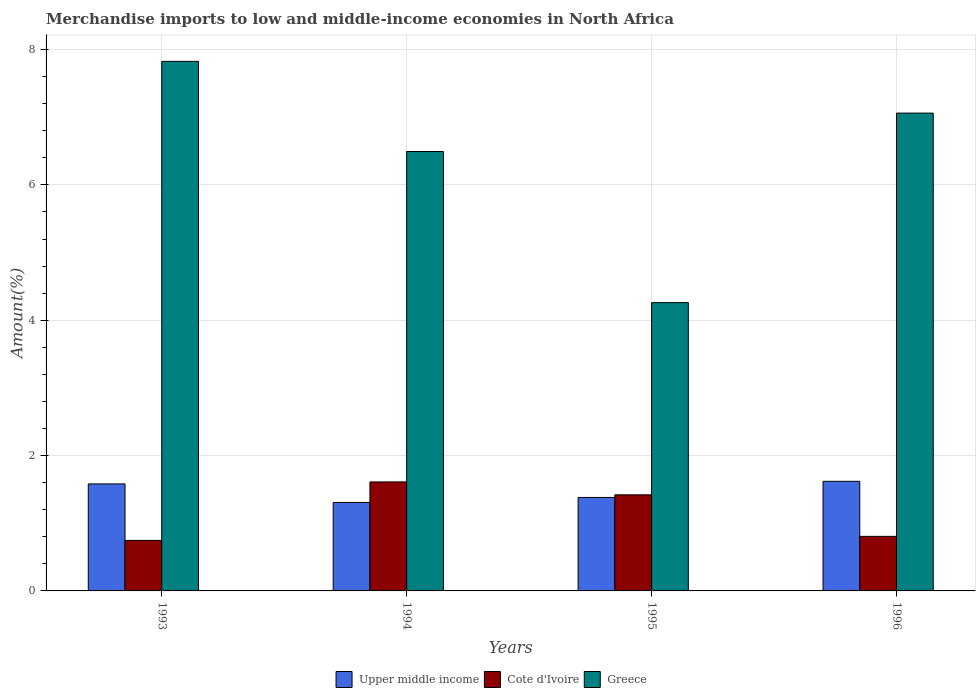How many groups of bars are there?
Your answer should be compact. 4. How many bars are there on the 1st tick from the left?
Offer a terse response. 3. What is the label of the 4th group of bars from the left?
Keep it short and to the point. 1996. What is the percentage of amount earned from merchandise imports in Greece in 1995?
Keep it short and to the point. 4.26. Across all years, what is the maximum percentage of amount earned from merchandise imports in Upper middle income?
Keep it short and to the point. 1.62. Across all years, what is the minimum percentage of amount earned from merchandise imports in Upper middle income?
Offer a terse response. 1.31. What is the total percentage of amount earned from merchandise imports in Upper middle income in the graph?
Keep it short and to the point. 5.89. What is the difference between the percentage of amount earned from merchandise imports in Upper middle income in 1994 and that in 1995?
Provide a short and direct response. -0.07. What is the difference between the percentage of amount earned from merchandise imports in Greece in 1993 and the percentage of amount earned from merchandise imports in Upper middle income in 1995?
Make the answer very short. 6.44. What is the average percentage of amount earned from merchandise imports in Greece per year?
Your answer should be very brief. 6.41. In the year 1996, what is the difference between the percentage of amount earned from merchandise imports in Cote d'Ivoire and percentage of amount earned from merchandise imports in Upper middle income?
Give a very brief answer. -0.81. In how many years, is the percentage of amount earned from merchandise imports in Upper middle income greater than 5.6 %?
Ensure brevity in your answer.  0. What is the ratio of the percentage of amount earned from merchandise imports in Greece in 1993 to that in 1995?
Your answer should be very brief. 1.84. Is the difference between the percentage of amount earned from merchandise imports in Cote d'Ivoire in 1993 and 1994 greater than the difference between the percentage of amount earned from merchandise imports in Upper middle income in 1993 and 1994?
Ensure brevity in your answer.  No. What is the difference between the highest and the second highest percentage of amount earned from merchandise imports in Greece?
Keep it short and to the point. 0.76. What is the difference between the highest and the lowest percentage of amount earned from merchandise imports in Upper middle income?
Offer a terse response. 0.31. In how many years, is the percentage of amount earned from merchandise imports in Cote d'Ivoire greater than the average percentage of amount earned from merchandise imports in Cote d'Ivoire taken over all years?
Provide a succinct answer. 2. Is the sum of the percentage of amount earned from merchandise imports in Cote d'Ivoire in 1993 and 1996 greater than the maximum percentage of amount earned from merchandise imports in Greece across all years?
Your response must be concise. No. What does the 1st bar from the left in 1995 represents?
Offer a very short reply. Upper middle income. Are all the bars in the graph horizontal?
Ensure brevity in your answer.  No. What is the difference between two consecutive major ticks on the Y-axis?
Your answer should be very brief. 2. Does the graph contain any zero values?
Your answer should be very brief. No. How many legend labels are there?
Give a very brief answer. 3. What is the title of the graph?
Provide a short and direct response. Merchandise imports to low and middle-income economies in North Africa. Does "Niger" appear as one of the legend labels in the graph?
Give a very brief answer. No. What is the label or title of the Y-axis?
Your answer should be very brief. Amount(%). What is the Amount(%) of Upper middle income in 1993?
Your answer should be very brief. 1.58. What is the Amount(%) of Cote d'Ivoire in 1993?
Give a very brief answer. 0.75. What is the Amount(%) in Greece in 1993?
Make the answer very short. 7.83. What is the Amount(%) of Upper middle income in 1994?
Your answer should be very brief. 1.31. What is the Amount(%) in Cote d'Ivoire in 1994?
Offer a terse response. 1.61. What is the Amount(%) in Greece in 1994?
Provide a succinct answer. 6.49. What is the Amount(%) of Upper middle income in 1995?
Provide a succinct answer. 1.38. What is the Amount(%) in Cote d'Ivoire in 1995?
Your answer should be compact. 1.42. What is the Amount(%) of Greece in 1995?
Your response must be concise. 4.26. What is the Amount(%) in Upper middle income in 1996?
Keep it short and to the point. 1.62. What is the Amount(%) of Cote d'Ivoire in 1996?
Offer a very short reply. 0.81. What is the Amount(%) in Greece in 1996?
Your answer should be compact. 7.06. Across all years, what is the maximum Amount(%) of Upper middle income?
Your answer should be very brief. 1.62. Across all years, what is the maximum Amount(%) of Cote d'Ivoire?
Offer a terse response. 1.61. Across all years, what is the maximum Amount(%) in Greece?
Provide a succinct answer. 7.83. Across all years, what is the minimum Amount(%) of Upper middle income?
Your answer should be compact. 1.31. Across all years, what is the minimum Amount(%) in Cote d'Ivoire?
Give a very brief answer. 0.75. Across all years, what is the minimum Amount(%) in Greece?
Your response must be concise. 4.26. What is the total Amount(%) in Upper middle income in the graph?
Offer a very short reply. 5.89. What is the total Amount(%) in Cote d'Ivoire in the graph?
Keep it short and to the point. 4.58. What is the total Amount(%) of Greece in the graph?
Ensure brevity in your answer.  25.64. What is the difference between the Amount(%) in Upper middle income in 1993 and that in 1994?
Ensure brevity in your answer.  0.27. What is the difference between the Amount(%) of Cote d'Ivoire in 1993 and that in 1994?
Ensure brevity in your answer.  -0.86. What is the difference between the Amount(%) in Greece in 1993 and that in 1994?
Provide a short and direct response. 1.33. What is the difference between the Amount(%) in Upper middle income in 1993 and that in 1995?
Your answer should be compact. 0.2. What is the difference between the Amount(%) in Cote d'Ivoire in 1993 and that in 1995?
Offer a very short reply. -0.67. What is the difference between the Amount(%) in Greece in 1993 and that in 1995?
Ensure brevity in your answer.  3.57. What is the difference between the Amount(%) in Upper middle income in 1993 and that in 1996?
Make the answer very short. -0.04. What is the difference between the Amount(%) in Cote d'Ivoire in 1993 and that in 1996?
Provide a short and direct response. -0.06. What is the difference between the Amount(%) of Greece in 1993 and that in 1996?
Your answer should be very brief. 0.76. What is the difference between the Amount(%) of Upper middle income in 1994 and that in 1995?
Your answer should be compact. -0.07. What is the difference between the Amount(%) in Cote d'Ivoire in 1994 and that in 1995?
Keep it short and to the point. 0.19. What is the difference between the Amount(%) in Greece in 1994 and that in 1995?
Your response must be concise. 2.23. What is the difference between the Amount(%) of Upper middle income in 1994 and that in 1996?
Provide a short and direct response. -0.31. What is the difference between the Amount(%) of Cote d'Ivoire in 1994 and that in 1996?
Your answer should be compact. 0.8. What is the difference between the Amount(%) in Greece in 1994 and that in 1996?
Make the answer very short. -0.57. What is the difference between the Amount(%) of Upper middle income in 1995 and that in 1996?
Provide a short and direct response. -0.24. What is the difference between the Amount(%) of Cote d'Ivoire in 1995 and that in 1996?
Your response must be concise. 0.61. What is the difference between the Amount(%) of Greece in 1995 and that in 1996?
Keep it short and to the point. -2.8. What is the difference between the Amount(%) in Upper middle income in 1993 and the Amount(%) in Cote d'Ivoire in 1994?
Ensure brevity in your answer.  -0.03. What is the difference between the Amount(%) in Upper middle income in 1993 and the Amount(%) in Greece in 1994?
Provide a succinct answer. -4.91. What is the difference between the Amount(%) in Cote d'Ivoire in 1993 and the Amount(%) in Greece in 1994?
Offer a very short reply. -5.75. What is the difference between the Amount(%) of Upper middle income in 1993 and the Amount(%) of Cote d'Ivoire in 1995?
Your response must be concise. 0.16. What is the difference between the Amount(%) in Upper middle income in 1993 and the Amount(%) in Greece in 1995?
Make the answer very short. -2.68. What is the difference between the Amount(%) of Cote d'Ivoire in 1993 and the Amount(%) of Greece in 1995?
Offer a very short reply. -3.51. What is the difference between the Amount(%) of Upper middle income in 1993 and the Amount(%) of Cote d'Ivoire in 1996?
Keep it short and to the point. 0.78. What is the difference between the Amount(%) of Upper middle income in 1993 and the Amount(%) of Greece in 1996?
Ensure brevity in your answer.  -5.48. What is the difference between the Amount(%) of Cote d'Ivoire in 1993 and the Amount(%) of Greece in 1996?
Give a very brief answer. -6.31. What is the difference between the Amount(%) in Upper middle income in 1994 and the Amount(%) in Cote d'Ivoire in 1995?
Offer a terse response. -0.11. What is the difference between the Amount(%) in Upper middle income in 1994 and the Amount(%) in Greece in 1995?
Your answer should be compact. -2.95. What is the difference between the Amount(%) of Cote d'Ivoire in 1994 and the Amount(%) of Greece in 1995?
Your response must be concise. -2.65. What is the difference between the Amount(%) in Upper middle income in 1994 and the Amount(%) in Cote d'Ivoire in 1996?
Offer a very short reply. 0.5. What is the difference between the Amount(%) in Upper middle income in 1994 and the Amount(%) in Greece in 1996?
Offer a very short reply. -5.75. What is the difference between the Amount(%) in Cote d'Ivoire in 1994 and the Amount(%) in Greece in 1996?
Keep it short and to the point. -5.45. What is the difference between the Amount(%) of Upper middle income in 1995 and the Amount(%) of Cote d'Ivoire in 1996?
Your response must be concise. 0.58. What is the difference between the Amount(%) of Upper middle income in 1995 and the Amount(%) of Greece in 1996?
Your answer should be very brief. -5.68. What is the difference between the Amount(%) in Cote d'Ivoire in 1995 and the Amount(%) in Greece in 1996?
Offer a very short reply. -5.64. What is the average Amount(%) of Upper middle income per year?
Your answer should be very brief. 1.47. What is the average Amount(%) of Cote d'Ivoire per year?
Offer a terse response. 1.15. What is the average Amount(%) in Greece per year?
Your answer should be very brief. 6.41. In the year 1993, what is the difference between the Amount(%) in Upper middle income and Amount(%) in Cote d'Ivoire?
Offer a very short reply. 0.83. In the year 1993, what is the difference between the Amount(%) in Upper middle income and Amount(%) in Greece?
Offer a terse response. -6.25. In the year 1993, what is the difference between the Amount(%) of Cote d'Ivoire and Amount(%) of Greece?
Your answer should be very brief. -7.08. In the year 1994, what is the difference between the Amount(%) of Upper middle income and Amount(%) of Cote d'Ivoire?
Your answer should be compact. -0.3. In the year 1994, what is the difference between the Amount(%) in Upper middle income and Amount(%) in Greece?
Your answer should be very brief. -5.19. In the year 1994, what is the difference between the Amount(%) in Cote d'Ivoire and Amount(%) in Greece?
Keep it short and to the point. -4.88. In the year 1995, what is the difference between the Amount(%) in Upper middle income and Amount(%) in Cote d'Ivoire?
Your answer should be very brief. -0.04. In the year 1995, what is the difference between the Amount(%) in Upper middle income and Amount(%) in Greece?
Make the answer very short. -2.88. In the year 1995, what is the difference between the Amount(%) in Cote d'Ivoire and Amount(%) in Greece?
Provide a short and direct response. -2.84. In the year 1996, what is the difference between the Amount(%) of Upper middle income and Amount(%) of Cote d'Ivoire?
Your answer should be very brief. 0.81. In the year 1996, what is the difference between the Amount(%) of Upper middle income and Amount(%) of Greece?
Give a very brief answer. -5.44. In the year 1996, what is the difference between the Amount(%) in Cote d'Ivoire and Amount(%) in Greece?
Your answer should be very brief. -6.26. What is the ratio of the Amount(%) in Upper middle income in 1993 to that in 1994?
Your answer should be compact. 1.21. What is the ratio of the Amount(%) of Cote d'Ivoire in 1993 to that in 1994?
Keep it short and to the point. 0.46. What is the ratio of the Amount(%) in Greece in 1993 to that in 1994?
Give a very brief answer. 1.21. What is the ratio of the Amount(%) of Upper middle income in 1993 to that in 1995?
Offer a very short reply. 1.14. What is the ratio of the Amount(%) in Cote d'Ivoire in 1993 to that in 1995?
Keep it short and to the point. 0.53. What is the ratio of the Amount(%) of Greece in 1993 to that in 1995?
Your answer should be very brief. 1.84. What is the ratio of the Amount(%) in Upper middle income in 1993 to that in 1996?
Your response must be concise. 0.98. What is the ratio of the Amount(%) in Cote d'Ivoire in 1993 to that in 1996?
Ensure brevity in your answer.  0.93. What is the ratio of the Amount(%) of Greece in 1993 to that in 1996?
Your response must be concise. 1.11. What is the ratio of the Amount(%) of Upper middle income in 1994 to that in 1995?
Make the answer very short. 0.95. What is the ratio of the Amount(%) of Cote d'Ivoire in 1994 to that in 1995?
Keep it short and to the point. 1.13. What is the ratio of the Amount(%) in Greece in 1994 to that in 1995?
Your answer should be very brief. 1.52. What is the ratio of the Amount(%) in Upper middle income in 1994 to that in 1996?
Provide a succinct answer. 0.81. What is the ratio of the Amount(%) in Cote d'Ivoire in 1994 to that in 1996?
Provide a short and direct response. 2. What is the ratio of the Amount(%) of Greece in 1994 to that in 1996?
Your answer should be very brief. 0.92. What is the ratio of the Amount(%) of Upper middle income in 1995 to that in 1996?
Ensure brevity in your answer.  0.85. What is the ratio of the Amount(%) of Cote d'Ivoire in 1995 to that in 1996?
Offer a terse response. 1.76. What is the ratio of the Amount(%) in Greece in 1995 to that in 1996?
Make the answer very short. 0.6. What is the difference between the highest and the second highest Amount(%) of Upper middle income?
Offer a terse response. 0.04. What is the difference between the highest and the second highest Amount(%) of Cote d'Ivoire?
Your answer should be compact. 0.19. What is the difference between the highest and the second highest Amount(%) in Greece?
Your response must be concise. 0.76. What is the difference between the highest and the lowest Amount(%) in Upper middle income?
Ensure brevity in your answer.  0.31. What is the difference between the highest and the lowest Amount(%) in Cote d'Ivoire?
Provide a short and direct response. 0.86. What is the difference between the highest and the lowest Amount(%) of Greece?
Give a very brief answer. 3.57. 